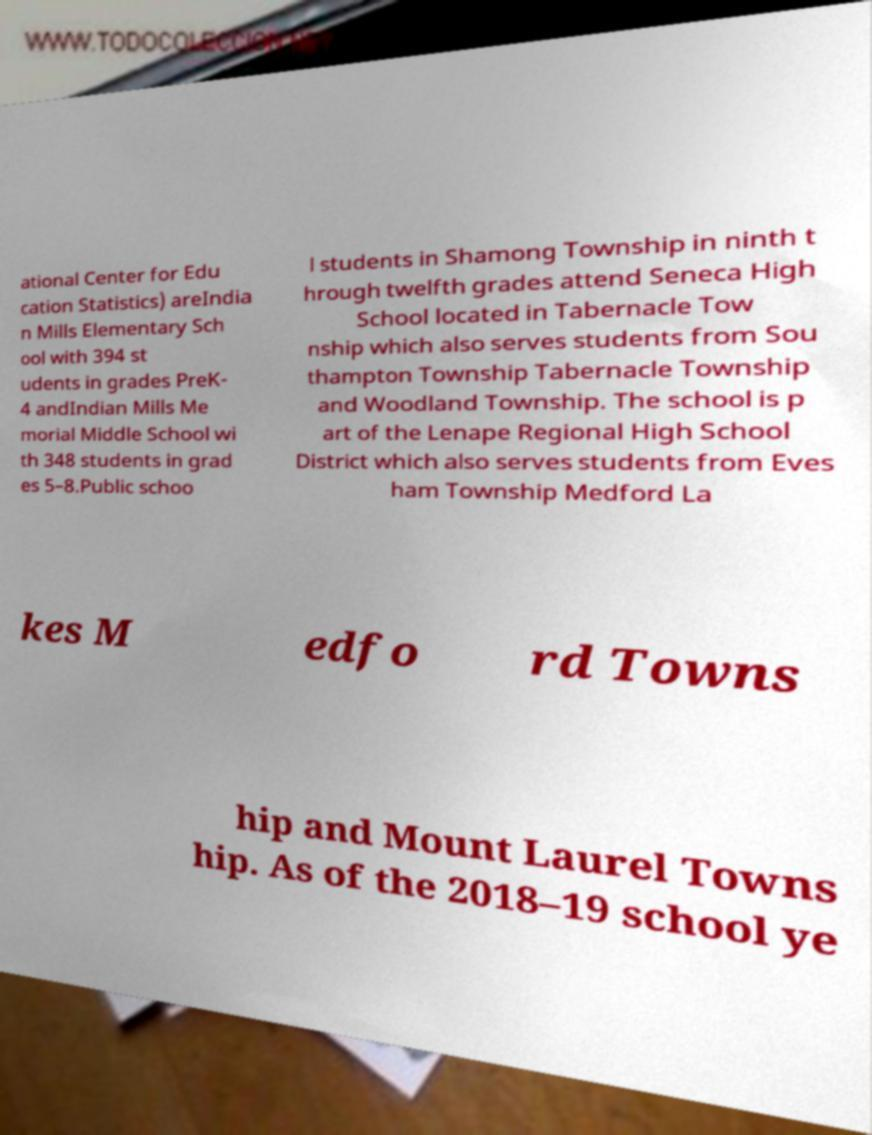Can you accurately transcribe the text from the provided image for me? ational Center for Edu cation Statistics) areIndia n Mills Elementary Sch ool with 394 st udents in grades PreK- 4 andIndian Mills Me morial Middle School wi th 348 students in grad es 5–8.Public schoo l students in Shamong Township in ninth t hrough twelfth grades attend Seneca High School located in Tabernacle Tow nship which also serves students from Sou thampton Township Tabernacle Township and Woodland Township. The school is p art of the Lenape Regional High School District which also serves students from Eves ham Township Medford La kes M edfo rd Towns hip and Mount Laurel Towns hip. As of the 2018–19 school ye 